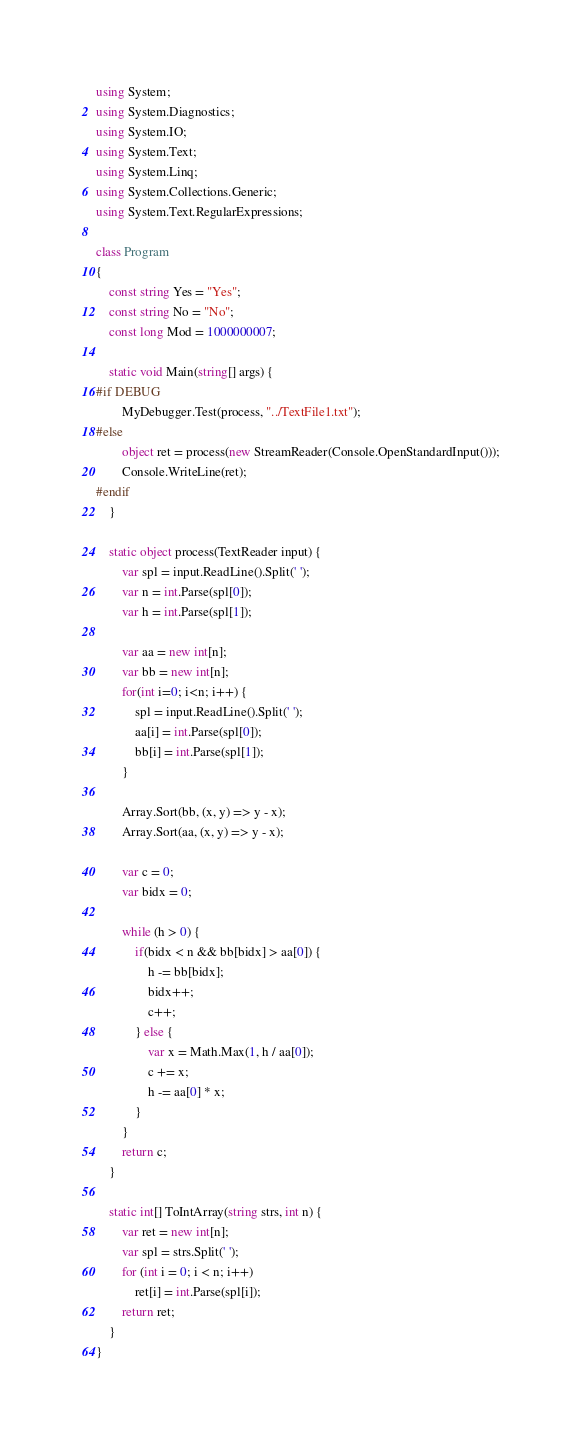Convert code to text. <code><loc_0><loc_0><loc_500><loc_500><_C#_>using System;
using System.Diagnostics;
using System.IO;
using System.Text;
using System.Linq;
using System.Collections.Generic;
using System.Text.RegularExpressions;

class Program
{
    const string Yes = "Yes";
    const string No = "No";
    const long Mod = 1000000007;

    static void Main(string[] args) {
#if DEBUG
        MyDebugger.Test(process, "../TextFile1.txt");
#else
        object ret = process(new StreamReader(Console.OpenStandardInput()));
        Console.WriteLine(ret);
#endif
    }

    static object process(TextReader input) {
        var spl = input.ReadLine().Split(' ');
        var n = int.Parse(spl[0]);
        var h = int.Parse(spl[1]);

        var aa = new int[n];
        var bb = new int[n];
        for(int i=0; i<n; i++) {
            spl = input.ReadLine().Split(' ');
            aa[i] = int.Parse(spl[0]);
            bb[i] = int.Parse(spl[1]);
        }

        Array.Sort(bb, (x, y) => y - x);
        Array.Sort(aa, (x, y) => y - x);

        var c = 0;
        var bidx = 0;

        while (h > 0) {
            if(bidx < n && bb[bidx] > aa[0]) {
                h -= bb[bidx];
                bidx++;
                c++;
            } else {
                var x = Math.Max(1, h / aa[0]);
                c += x;
                h -= aa[0] * x;
            }
        }
        return c;
    }

    static int[] ToIntArray(string strs, int n) {
        var ret = new int[n];
        var spl = strs.Split(' ');
        for (int i = 0; i < n; i++)
            ret[i] = int.Parse(spl[i]);
        return ret;
    }
}
</code> 